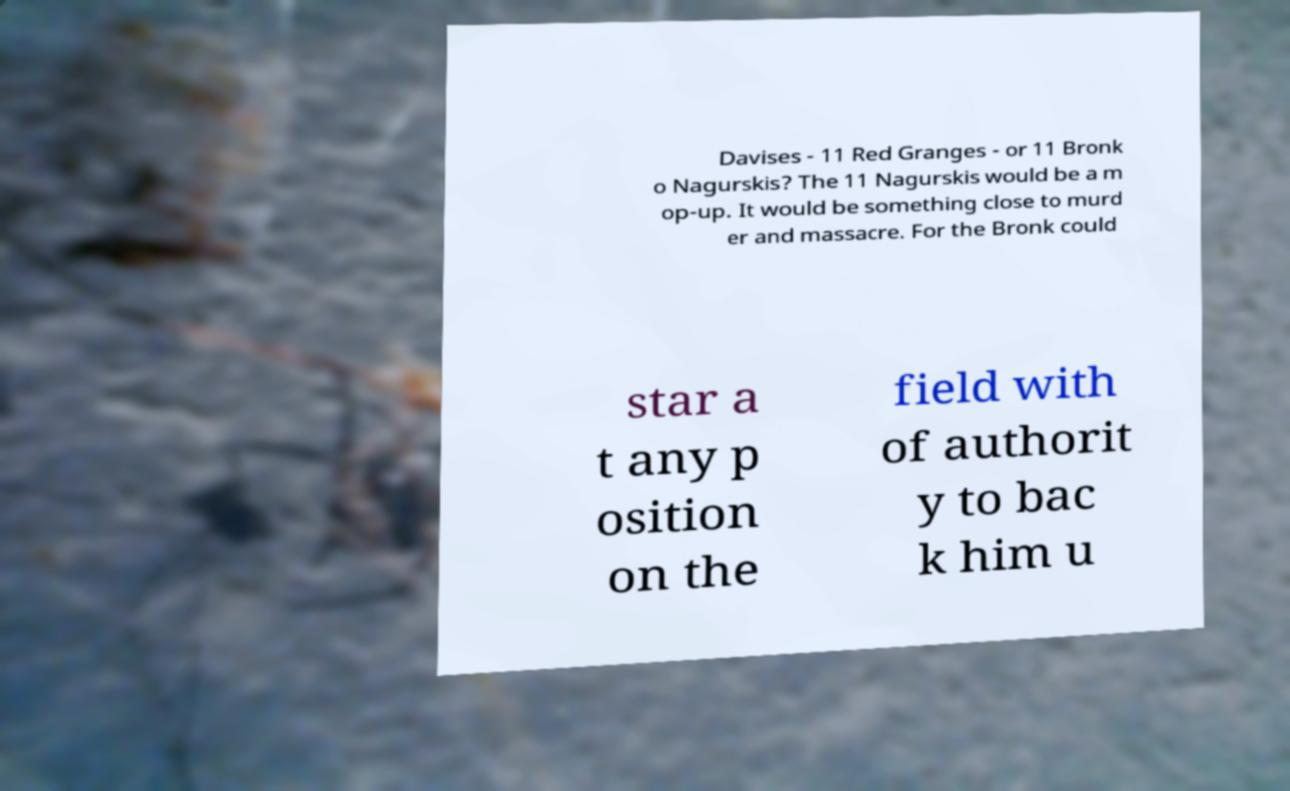Can you accurately transcribe the text from the provided image for me? Davises - 11 Red Granges - or 11 Bronk o Nagurskis? The 11 Nagurskis would be a m op-up. It would be something close to murd er and massacre. For the Bronk could star a t any p osition on the field with of authorit y to bac k him u 